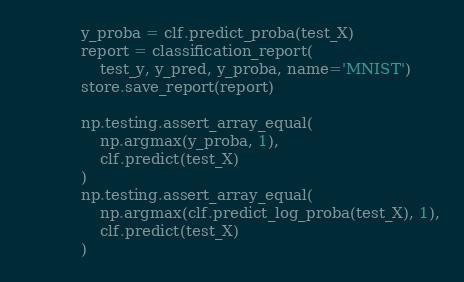Convert code to text. <code><loc_0><loc_0><loc_500><loc_500><_Python_>            y_proba = clf.predict_proba(test_X)
            report = classification_report(
                test_y, y_pred, y_proba, name='MNIST')
            store.save_report(report)

            np.testing.assert_array_equal(
                np.argmax(y_proba, 1),
                clf.predict(test_X)
            )
            np.testing.assert_array_equal(
                np.argmax(clf.predict_log_proba(test_X), 1),
                clf.predict(test_X)
            )
</code> 